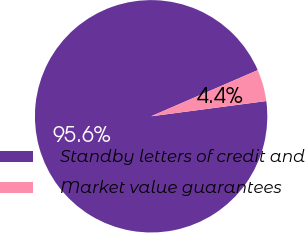Convert chart. <chart><loc_0><loc_0><loc_500><loc_500><pie_chart><fcel>Standby letters of credit and<fcel>Market value guarantees<nl><fcel>95.59%<fcel>4.41%<nl></chart> 